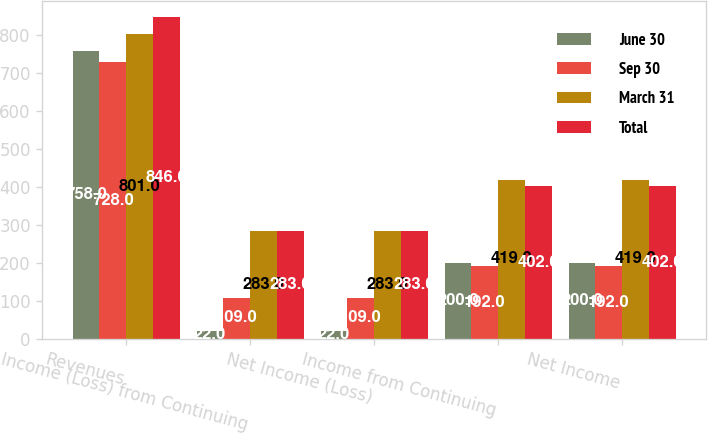<chart> <loc_0><loc_0><loc_500><loc_500><stacked_bar_chart><ecel><fcel>Revenues<fcel>Income (Loss) from Continuing<fcel>Net Income (Loss)<fcel>Income from Continuing<fcel>Net Income<nl><fcel>June 30<fcel>758<fcel>22<fcel>22<fcel>200<fcel>200<nl><fcel>Sep 30<fcel>728<fcel>109<fcel>109<fcel>192<fcel>192<nl><fcel>March 31<fcel>801<fcel>283<fcel>283<fcel>419<fcel>419<nl><fcel>Total<fcel>846<fcel>283<fcel>283<fcel>402<fcel>402<nl></chart> 